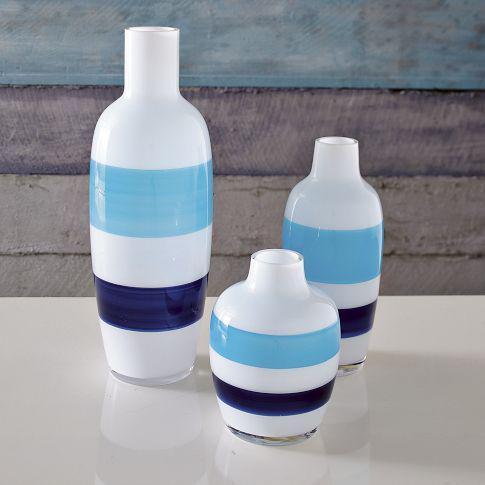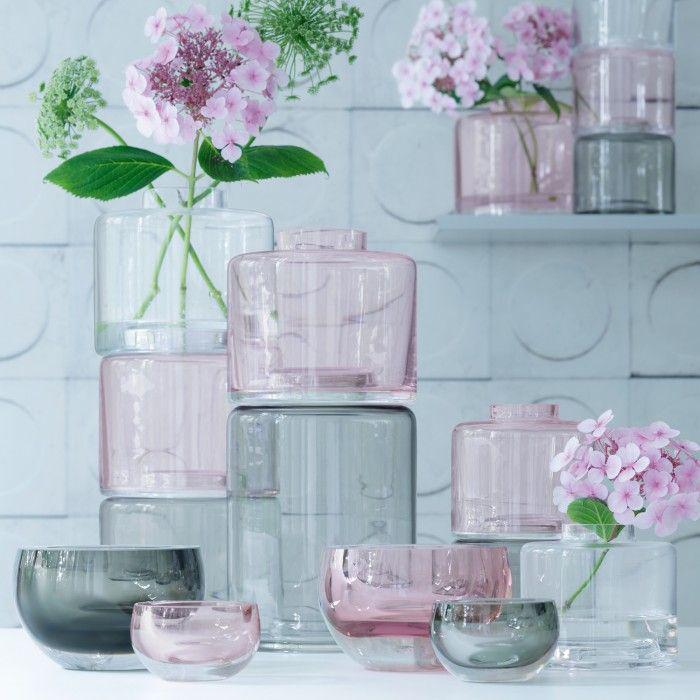The first image is the image on the left, the second image is the image on the right. Given the left and right images, does the statement "An image shows vases with bold horizontal bands of color." hold true? Answer yes or no. Yes. 